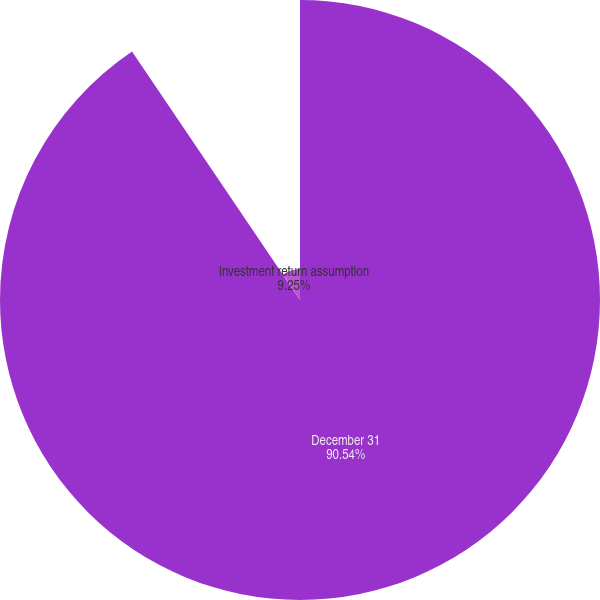Convert chart. <chart><loc_0><loc_0><loc_500><loc_500><pie_chart><fcel>December 31<fcel>Discount rate<fcel>Investment return assumption<nl><fcel>90.54%<fcel>0.21%<fcel>9.25%<nl></chart> 